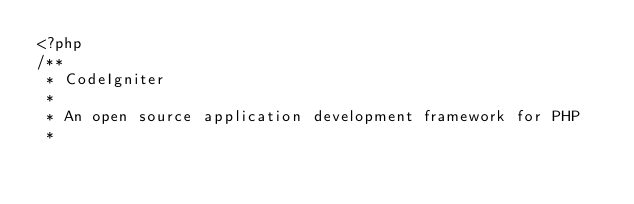<code> <loc_0><loc_0><loc_500><loc_500><_PHP_><?php
/**
 * CodeIgniter
 *
 * An open source application development framework for PHP
 *</code> 